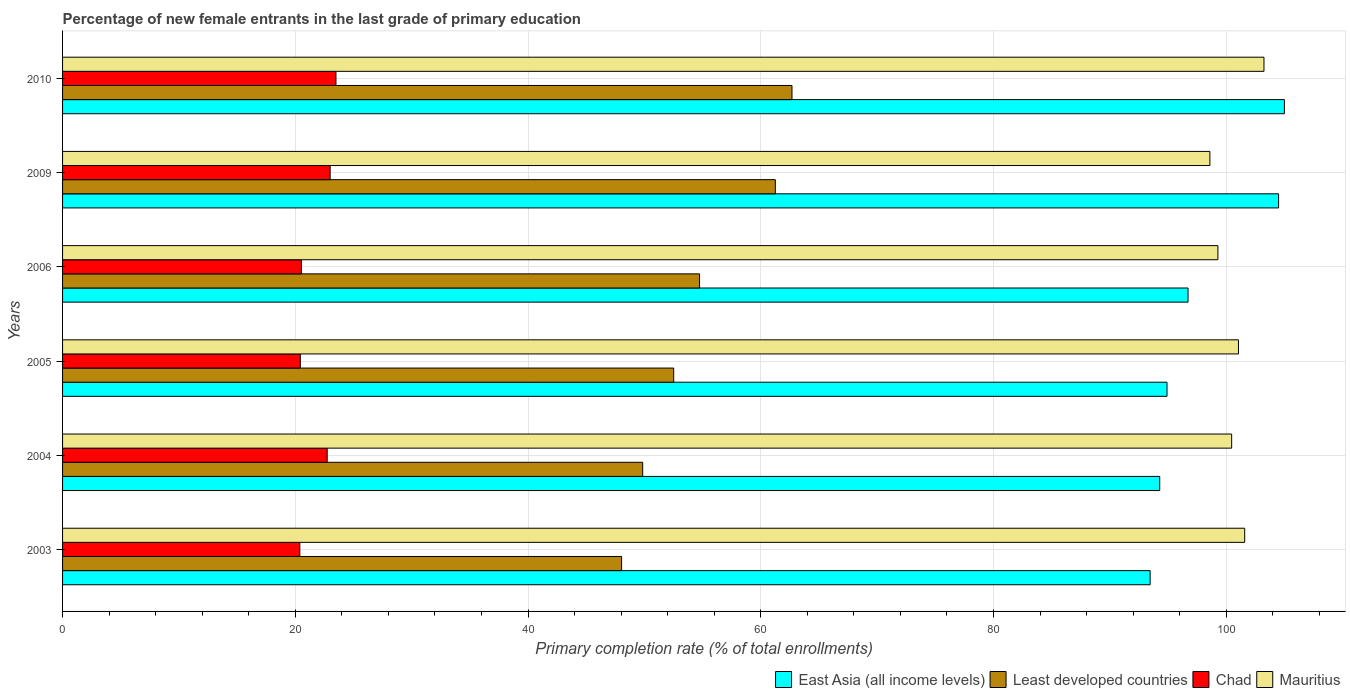How many different coloured bars are there?
Offer a very short reply. 4. How many bars are there on the 6th tick from the top?
Provide a succinct answer. 4. What is the label of the 6th group of bars from the top?
Ensure brevity in your answer.  2003. What is the percentage of new female entrants in Least developed countries in 2010?
Offer a very short reply. 62.68. Across all years, what is the maximum percentage of new female entrants in Least developed countries?
Your answer should be very brief. 62.68. Across all years, what is the minimum percentage of new female entrants in East Asia (all income levels)?
Provide a short and direct response. 93.46. What is the total percentage of new female entrants in East Asia (all income levels) in the graph?
Your answer should be compact. 588.85. What is the difference between the percentage of new female entrants in East Asia (all income levels) in 2004 and that in 2005?
Your response must be concise. -0.63. What is the difference between the percentage of new female entrants in East Asia (all income levels) in 2004 and the percentage of new female entrants in Chad in 2003?
Your answer should be very brief. 73.89. What is the average percentage of new female entrants in Chad per year?
Keep it short and to the point. 21.76. In the year 2005, what is the difference between the percentage of new female entrants in Least developed countries and percentage of new female entrants in East Asia (all income levels)?
Make the answer very short. -42.39. What is the ratio of the percentage of new female entrants in Mauritius in 2005 to that in 2009?
Your response must be concise. 1.02. Is the percentage of new female entrants in Mauritius in 2004 less than that in 2010?
Ensure brevity in your answer.  Yes. Is the difference between the percentage of new female entrants in Least developed countries in 2004 and 2005 greater than the difference between the percentage of new female entrants in East Asia (all income levels) in 2004 and 2005?
Ensure brevity in your answer.  No. What is the difference between the highest and the second highest percentage of new female entrants in Mauritius?
Provide a short and direct response. 1.66. What is the difference between the highest and the lowest percentage of new female entrants in Least developed countries?
Give a very brief answer. 14.64. What does the 4th bar from the top in 2010 represents?
Provide a succinct answer. East Asia (all income levels). What does the 1st bar from the bottom in 2009 represents?
Offer a terse response. East Asia (all income levels). Is it the case that in every year, the sum of the percentage of new female entrants in Chad and percentage of new female entrants in Least developed countries is greater than the percentage of new female entrants in Mauritius?
Your answer should be very brief. No. Are all the bars in the graph horizontal?
Give a very brief answer. Yes. How many years are there in the graph?
Offer a terse response. 6. What is the difference between two consecutive major ticks on the X-axis?
Your response must be concise. 20. Are the values on the major ticks of X-axis written in scientific E-notation?
Your answer should be compact. No. Does the graph contain grids?
Make the answer very short. Yes. How are the legend labels stacked?
Offer a terse response. Horizontal. What is the title of the graph?
Offer a very short reply. Percentage of new female entrants in the last grade of primary education. What is the label or title of the X-axis?
Your answer should be very brief. Primary completion rate (% of total enrollments). What is the Primary completion rate (% of total enrollments) in East Asia (all income levels) in 2003?
Offer a terse response. 93.46. What is the Primary completion rate (% of total enrollments) in Least developed countries in 2003?
Offer a very short reply. 48.04. What is the Primary completion rate (% of total enrollments) in Chad in 2003?
Your answer should be very brief. 20.39. What is the Primary completion rate (% of total enrollments) of Mauritius in 2003?
Keep it short and to the point. 101.58. What is the Primary completion rate (% of total enrollments) in East Asia (all income levels) in 2004?
Your answer should be compact. 94.28. What is the Primary completion rate (% of total enrollments) of Least developed countries in 2004?
Your answer should be very brief. 49.85. What is the Primary completion rate (% of total enrollments) in Chad in 2004?
Ensure brevity in your answer.  22.74. What is the Primary completion rate (% of total enrollments) of Mauritius in 2004?
Your answer should be very brief. 100.46. What is the Primary completion rate (% of total enrollments) in East Asia (all income levels) in 2005?
Offer a very short reply. 94.91. What is the Primary completion rate (% of total enrollments) of Least developed countries in 2005?
Keep it short and to the point. 52.52. What is the Primary completion rate (% of total enrollments) in Chad in 2005?
Provide a succinct answer. 20.43. What is the Primary completion rate (% of total enrollments) in Mauritius in 2005?
Keep it short and to the point. 101.05. What is the Primary completion rate (% of total enrollments) in East Asia (all income levels) in 2006?
Your answer should be very brief. 96.72. What is the Primary completion rate (% of total enrollments) of Least developed countries in 2006?
Provide a succinct answer. 54.74. What is the Primary completion rate (% of total enrollments) of Chad in 2006?
Offer a very short reply. 20.52. What is the Primary completion rate (% of total enrollments) of Mauritius in 2006?
Your answer should be compact. 99.28. What is the Primary completion rate (% of total enrollments) in East Asia (all income levels) in 2009?
Provide a succinct answer. 104.49. What is the Primary completion rate (% of total enrollments) of Least developed countries in 2009?
Your response must be concise. 61.25. What is the Primary completion rate (% of total enrollments) in Chad in 2009?
Your answer should be very brief. 22.99. What is the Primary completion rate (% of total enrollments) in Mauritius in 2009?
Your response must be concise. 98.59. What is the Primary completion rate (% of total enrollments) of East Asia (all income levels) in 2010?
Provide a succinct answer. 104.99. What is the Primary completion rate (% of total enrollments) in Least developed countries in 2010?
Your response must be concise. 62.68. What is the Primary completion rate (% of total enrollments) in Chad in 2010?
Offer a very short reply. 23.49. What is the Primary completion rate (% of total enrollments) of Mauritius in 2010?
Keep it short and to the point. 103.24. Across all years, what is the maximum Primary completion rate (% of total enrollments) of East Asia (all income levels)?
Make the answer very short. 104.99. Across all years, what is the maximum Primary completion rate (% of total enrollments) in Least developed countries?
Keep it short and to the point. 62.68. Across all years, what is the maximum Primary completion rate (% of total enrollments) in Chad?
Offer a very short reply. 23.49. Across all years, what is the maximum Primary completion rate (% of total enrollments) in Mauritius?
Your response must be concise. 103.24. Across all years, what is the minimum Primary completion rate (% of total enrollments) in East Asia (all income levels)?
Your answer should be compact. 93.46. Across all years, what is the minimum Primary completion rate (% of total enrollments) in Least developed countries?
Your answer should be very brief. 48.04. Across all years, what is the minimum Primary completion rate (% of total enrollments) of Chad?
Provide a short and direct response. 20.39. Across all years, what is the minimum Primary completion rate (% of total enrollments) in Mauritius?
Keep it short and to the point. 98.59. What is the total Primary completion rate (% of total enrollments) of East Asia (all income levels) in the graph?
Offer a very short reply. 588.85. What is the total Primary completion rate (% of total enrollments) in Least developed countries in the graph?
Your answer should be compact. 329.07. What is the total Primary completion rate (% of total enrollments) in Chad in the graph?
Offer a terse response. 130.57. What is the total Primary completion rate (% of total enrollments) of Mauritius in the graph?
Make the answer very short. 604.2. What is the difference between the Primary completion rate (% of total enrollments) of East Asia (all income levels) in 2003 and that in 2004?
Make the answer very short. -0.82. What is the difference between the Primary completion rate (% of total enrollments) in Least developed countries in 2003 and that in 2004?
Offer a terse response. -1.81. What is the difference between the Primary completion rate (% of total enrollments) in Chad in 2003 and that in 2004?
Your answer should be very brief. -2.35. What is the difference between the Primary completion rate (% of total enrollments) in Mauritius in 2003 and that in 2004?
Offer a terse response. 1.12. What is the difference between the Primary completion rate (% of total enrollments) of East Asia (all income levels) in 2003 and that in 2005?
Give a very brief answer. -1.45. What is the difference between the Primary completion rate (% of total enrollments) in Least developed countries in 2003 and that in 2005?
Your answer should be very brief. -4.48. What is the difference between the Primary completion rate (% of total enrollments) of Chad in 2003 and that in 2005?
Provide a short and direct response. -0.04. What is the difference between the Primary completion rate (% of total enrollments) of Mauritius in 2003 and that in 2005?
Your response must be concise. 0.53. What is the difference between the Primary completion rate (% of total enrollments) of East Asia (all income levels) in 2003 and that in 2006?
Your answer should be compact. -3.26. What is the difference between the Primary completion rate (% of total enrollments) in Least developed countries in 2003 and that in 2006?
Keep it short and to the point. -6.7. What is the difference between the Primary completion rate (% of total enrollments) in Chad in 2003 and that in 2006?
Keep it short and to the point. -0.13. What is the difference between the Primary completion rate (% of total enrollments) of Mauritius in 2003 and that in 2006?
Give a very brief answer. 2.3. What is the difference between the Primary completion rate (% of total enrollments) in East Asia (all income levels) in 2003 and that in 2009?
Keep it short and to the point. -11.04. What is the difference between the Primary completion rate (% of total enrollments) in Least developed countries in 2003 and that in 2009?
Your response must be concise. -13.21. What is the difference between the Primary completion rate (% of total enrollments) in Chad in 2003 and that in 2009?
Provide a succinct answer. -2.6. What is the difference between the Primary completion rate (% of total enrollments) in Mauritius in 2003 and that in 2009?
Provide a succinct answer. 2.99. What is the difference between the Primary completion rate (% of total enrollments) of East Asia (all income levels) in 2003 and that in 2010?
Your answer should be compact. -11.54. What is the difference between the Primary completion rate (% of total enrollments) in Least developed countries in 2003 and that in 2010?
Your answer should be compact. -14.64. What is the difference between the Primary completion rate (% of total enrollments) in Chad in 2003 and that in 2010?
Provide a short and direct response. -3.1. What is the difference between the Primary completion rate (% of total enrollments) in Mauritius in 2003 and that in 2010?
Offer a very short reply. -1.66. What is the difference between the Primary completion rate (% of total enrollments) in East Asia (all income levels) in 2004 and that in 2005?
Your answer should be compact. -0.63. What is the difference between the Primary completion rate (% of total enrollments) in Least developed countries in 2004 and that in 2005?
Keep it short and to the point. -2.67. What is the difference between the Primary completion rate (% of total enrollments) of Chad in 2004 and that in 2005?
Keep it short and to the point. 2.31. What is the difference between the Primary completion rate (% of total enrollments) of Mauritius in 2004 and that in 2005?
Offer a very short reply. -0.59. What is the difference between the Primary completion rate (% of total enrollments) of East Asia (all income levels) in 2004 and that in 2006?
Provide a succinct answer. -2.44. What is the difference between the Primary completion rate (% of total enrollments) of Least developed countries in 2004 and that in 2006?
Your answer should be very brief. -4.89. What is the difference between the Primary completion rate (% of total enrollments) in Chad in 2004 and that in 2006?
Give a very brief answer. 2.22. What is the difference between the Primary completion rate (% of total enrollments) in Mauritius in 2004 and that in 2006?
Offer a terse response. 1.18. What is the difference between the Primary completion rate (% of total enrollments) of East Asia (all income levels) in 2004 and that in 2009?
Ensure brevity in your answer.  -10.21. What is the difference between the Primary completion rate (% of total enrollments) in Least developed countries in 2004 and that in 2009?
Ensure brevity in your answer.  -11.4. What is the difference between the Primary completion rate (% of total enrollments) in Chad in 2004 and that in 2009?
Make the answer very short. -0.25. What is the difference between the Primary completion rate (% of total enrollments) of Mauritius in 2004 and that in 2009?
Your response must be concise. 1.87. What is the difference between the Primary completion rate (% of total enrollments) in East Asia (all income levels) in 2004 and that in 2010?
Provide a succinct answer. -10.71. What is the difference between the Primary completion rate (% of total enrollments) of Least developed countries in 2004 and that in 2010?
Give a very brief answer. -12.83. What is the difference between the Primary completion rate (% of total enrollments) of Chad in 2004 and that in 2010?
Your response must be concise. -0.75. What is the difference between the Primary completion rate (% of total enrollments) in Mauritius in 2004 and that in 2010?
Give a very brief answer. -2.78. What is the difference between the Primary completion rate (% of total enrollments) of East Asia (all income levels) in 2005 and that in 2006?
Provide a short and direct response. -1.81. What is the difference between the Primary completion rate (% of total enrollments) of Least developed countries in 2005 and that in 2006?
Make the answer very short. -2.22. What is the difference between the Primary completion rate (% of total enrollments) of Chad in 2005 and that in 2006?
Ensure brevity in your answer.  -0.09. What is the difference between the Primary completion rate (% of total enrollments) in Mauritius in 2005 and that in 2006?
Provide a short and direct response. 1.77. What is the difference between the Primary completion rate (% of total enrollments) in East Asia (all income levels) in 2005 and that in 2009?
Provide a short and direct response. -9.59. What is the difference between the Primary completion rate (% of total enrollments) in Least developed countries in 2005 and that in 2009?
Provide a succinct answer. -8.73. What is the difference between the Primary completion rate (% of total enrollments) of Chad in 2005 and that in 2009?
Offer a very short reply. -2.56. What is the difference between the Primary completion rate (% of total enrollments) in Mauritius in 2005 and that in 2009?
Your response must be concise. 2.46. What is the difference between the Primary completion rate (% of total enrollments) of East Asia (all income levels) in 2005 and that in 2010?
Keep it short and to the point. -10.09. What is the difference between the Primary completion rate (% of total enrollments) of Least developed countries in 2005 and that in 2010?
Make the answer very short. -10.16. What is the difference between the Primary completion rate (% of total enrollments) of Chad in 2005 and that in 2010?
Your answer should be compact. -3.06. What is the difference between the Primary completion rate (% of total enrollments) of Mauritius in 2005 and that in 2010?
Keep it short and to the point. -2.19. What is the difference between the Primary completion rate (% of total enrollments) of East Asia (all income levels) in 2006 and that in 2009?
Make the answer very short. -7.78. What is the difference between the Primary completion rate (% of total enrollments) in Least developed countries in 2006 and that in 2009?
Your response must be concise. -6.51. What is the difference between the Primary completion rate (% of total enrollments) of Chad in 2006 and that in 2009?
Your answer should be compact. -2.47. What is the difference between the Primary completion rate (% of total enrollments) of Mauritius in 2006 and that in 2009?
Your answer should be very brief. 0.69. What is the difference between the Primary completion rate (% of total enrollments) in East Asia (all income levels) in 2006 and that in 2010?
Your answer should be very brief. -8.28. What is the difference between the Primary completion rate (% of total enrollments) of Least developed countries in 2006 and that in 2010?
Provide a succinct answer. -7.94. What is the difference between the Primary completion rate (% of total enrollments) of Chad in 2006 and that in 2010?
Your answer should be very brief. -2.97. What is the difference between the Primary completion rate (% of total enrollments) in Mauritius in 2006 and that in 2010?
Provide a short and direct response. -3.96. What is the difference between the Primary completion rate (% of total enrollments) of East Asia (all income levels) in 2009 and that in 2010?
Offer a very short reply. -0.5. What is the difference between the Primary completion rate (% of total enrollments) in Least developed countries in 2009 and that in 2010?
Offer a very short reply. -1.43. What is the difference between the Primary completion rate (% of total enrollments) of Mauritius in 2009 and that in 2010?
Provide a succinct answer. -4.65. What is the difference between the Primary completion rate (% of total enrollments) in East Asia (all income levels) in 2003 and the Primary completion rate (% of total enrollments) in Least developed countries in 2004?
Offer a terse response. 43.61. What is the difference between the Primary completion rate (% of total enrollments) in East Asia (all income levels) in 2003 and the Primary completion rate (% of total enrollments) in Chad in 2004?
Make the answer very short. 70.72. What is the difference between the Primary completion rate (% of total enrollments) of East Asia (all income levels) in 2003 and the Primary completion rate (% of total enrollments) of Mauritius in 2004?
Give a very brief answer. -7. What is the difference between the Primary completion rate (% of total enrollments) in Least developed countries in 2003 and the Primary completion rate (% of total enrollments) in Chad in 2004?
Your answer should be compact. 25.3. What is the difference between the Primary completion rate (% of total enrollments) in Least developed countries in 2003 and the Primary completion rate (% of total enrollments) in Mauritius in 2004?
Your answer should be compact. -52.42. What is the difference between the Primary completion rate (% of total enrollments) in Chad in 2003 and the Primary completion rate (% of total enrollments) in Mauritius in 2004?
Give a very brief answer. -80.07. What is the difference between the Primary completion rate (% of total enrollments) of East Asia (all income levels) in 2003 and the Primary completion rate (% of total enrollments) of Least developed countries in 2005?
Offer a very short reply. 40.94. What is the difference between the Primary completion rate (% of total enrollments) in East Asia (all income levels) in 2003 and the Primary completion rate (% of total enrollments) in Chad in 2005?
Give a very brief answer. 73.03. What is the difference between the Primary completion rate (% of total enrollments) in East Asia (all income levels) in 2003 and the Primary completion rate (% of total enrollments) in Mauritius in 2005?
Ensure brevity in your answer.  -7.59. What is the difference between the Primary completion rate (% of total enrollments) of Least developed countries in 2003 and the Primary completion rate (% of total enrollments) of Chad in 2005?
Your response must be concise. 27.61. What is the difference between the Primary completion rate (% of total enrollments) in Least developed countries in 2003 and the Primary completion rate (% of total enrollments) in Mauritius in 2005?
Make the answer very short. -53.01. What is the difference between the Primary completion rate (% of total enrollments) of Chad in 2003 and the Primary completion rate (% of total enrollments) of Mauritius in 2005?
Your answer should be compact. -80.66. What is the difference between the Primary completion rate (% of total enrollments) of East Asia (all income levels) in 2003 and the Primary completion rate (% of total enrollments) of Least developed countries in 2006?
Offer a terse response. 38.72. What is the difference between the Primary completion rate (% of total enrollments) of East Asia (all income levels) in 2003 and the Primary completion rate (% of total enrollments) of Chad in 2006?
Your response must be concise. 72.94. What is the difference between the Primary completion rate (% of total enrollments) of East Asia (all income levels) in 2003 and the Primary completion rate (% of total enrollments) of Mauritius in 2006?
Offer a very short reply. -5.82. What is the difference between the Primary completion rate (% of total enrollments) in Least developed countries in 2003 and the Primary completion rate (% of total enrollments) in Chad in 2006?
Your response must be concise. 27.52. What is the difference between the Primary completion rate (% of total enrollments) in Least developed countries in 2003 and the Primary completion rate (% of total enrollments) in Mauritius in 2006?
Give a very brief answer. -51.24. What is the difference between the Primary completion rate (% of total enrollments) of Chad in 2003 and the Primary completion rate (% of total enrollments) of Mauritius in 2006?
Give a very brief answer. -78.89. What is the difference between the Primary completion rate (% of total enrollments) of East Asia (all income levels) in 2003 and the Primary completion rate (% of total enrollments) of Least developed countries in 2009?
Provide a short and direct response. 32.21. What is the difference between the Primary completion rate (% of total enrollments) in East Asia (all income levels) in 2003 and the Primary completion rate (% of total enrollments) in Chad in 2009?
Give a very brief answer. 70.46. What is the difference between the Primary completion rate (% of total enrollments) of East Asia (all income levels) in 2003 and the Primary completion rate (% of total enrollments) of Mauritius in 2009?
Provide a short and direct response. -5.13. What is the difference between the Primary completion rate (% of total enrollments) of Least developed countries in 2003 and the Primary completion rate (% of total enrollments) of Chad in 2009?
Provide a succinct answer. 25.05. What is the difference between the Primary completion rate (% of total enrollments) in Least developed countries in 2003 and the Primary completion rate (% of total enrollments) in Mauritius in 2009?
Your answer should be compact. -50.55. What is the difference between the Primary completion rate (% of total enrollments) in Chad in 2003 and the Primary completion rate (% of total enrollments) in Mauritius in 2009?
Give a very brief answer. -78.2. What is the difference between the Primary completion rate (% of total enrollments) in East Asia (all income levels) in 2003 and the Primary completion rate (% of total enrollments) in Least developed countries in 2010?
Keep it short and to the point. 30.78. What is the difference between the Primary completion rate (% of total enrollments) of East Asia (all income levels) in 2003 and the Primary completion rate (% of total enrollments) of Chad in 2010?
Offer a terse response. 69.96. What is the difference between the Primary completion rate (% of total enrollments) of East Asia (all income levels) in 2003 and the Primary completion rate (% of total enrollments) of Mauritius in 2010?
Provide a succinct answer. -9.78. What is the difference between the Primary completion rate (% of total enrollments) of Least developed countries in 2003 and the Primary completion rate (% of total enrollments) of Chad in 2010?
Keep it short and to the point. 24.55. What is the difference between the Primary completion rate (% of total enrollments) of Least developed countries in 2003 and the Primary completion rate (% of total enrollments) of Mauritius in 2010?
Give a very brief answer. -55.2. What is the difference between the Primary completion rate (% of total enrollments) in Chad in 2003 and the Primary completion rate (% of total enrollments) in Mauritius in 2010?
Provide a short and direct response. -82.85. What is the difference between the Primary completion rate (% of total enrollments) in East Asia (all income levels) in 2004 and the Primary completion rate (% of total enrollments) in Least developed countries in 2005?
Your answer should be very brief. 41.76. What is the difference between the Primary completion rate (% of total enrollments) of East Asia (all income levels) in 2004 and the Primary completion rate (% of total enrollments) of Chad in 2005?
Your answer should be compact. 73.85. What is the difference between the Primary completion rate (% of total enrollments) of East Asia (all income levels) in 2004 and the Primary completion rate (% of total enrollments) of Mauritius in 2005?
Your answer should be very brief. -6.77. What is the difference between the Primary completion rate (% of total enrollments) of Least developed countries in 2004 and the Primary completion rate (% of total enrollments) of Chad in 2005?
Provide a succinct answer. 29.42. What is the difference between the Primary completion rate (% of total enrollments) in Least developed countries in 2004 and the Primary completion rate (% of total enrollments) in Mauritius in 2005?
Your answer should be very brief. -51.2. What is the difference between the Primary completion rate (% of total enrollments) of Chad in 2004 and the Primary completion rate (% of total enrollments) of Mauritius in 2005?
Your answer should be compact. -78.31. What is the difference between the Primary completion rate (% of total enrollments) in East Asia (all income levels) in 2004 and the Primary completion rate (% of total enrollments) in Least developed countries in 2006?
Your response must be concise. 39.54. What is the difference between the Primary completion rate (% of total enrollments) of East Asia (all income levels) in 2004 and the Primary completion rate (% of total enrollments) of Chad in 2006?
Keep it short and to the point. 73.76. What is the difference between the Primary completion rate (% of total enrollments) in East Asia (all income levels) in 2004 and the Primary completion rate (% of total enrollments) in Mauritius in 2006?
Offer a very short reply. -5. What is the difference between the Primary completion rate (% of total enrollments) in Least developed countries in 2004 and the Primary completion rate (% of total enrollments) in Chad in 2006?
Offer a terse response. 29.33. What is the difference between the Primary completion rate (% of total enrollments) in Least developed countries in 2004 and the Primary completion rate (% of total enrollments) in Mauritius in 2006?
Offer a very short reply. -49.43. What is the difference between the Primary completion rate (% of total enrollments) in Chad in 2004 and the Primary completion rate (% of total enrollments) in Mauritius in 2006?
Make the answer very short. -76.54. What is the difference between the Primary completion rate (% of total enrollments) in East Asia (all income levels) in 2004 and the Primary completion rate (% of total enrollments) in Least developed countries in 2009?
Offer a terse response. 33.03. What is the difference between the Primary completion rate (% of total enrollments) of East Asia (all income levels) in 2004 and the Primary completion rate (% of total enrollments) of Chad in 2009?
Give a very brief answer. 71.29. What is the difference between the Primary completion rate (% of total enrollments) of East Asia (all income levels) in 2004 and the Primary completion rate (% of total enrollments) of Mauritius in 2009?
Your response must be concise. -4.31. What is the difference between the Primary completion rate (% of total enrollments) of Least developed countries in 2004 and the Primary completion rate (% of total enrollments) of Chad in 2009?
Offer a very short reply. 26.86. What is the difference between the Primary completion rate (% of total enrollments) of Least developed countries in 2004 and the Primary completion rate (% of total enrollments) of Mauritius in 2009?
Offer a terse response. -48.74. What is the difference between the Primary completion rate (% of total enrollments) of Chad in 2004 and the Primary completion rate (% of total enrollments) of Mauritius in 2009?
Your response must be concise. -75.85. What is the difference between the Primary completion rate (% of total enrollments) of East Asia (all income levels) in 2004 and the Primary completion rate (% of total enrollments) of Least developed countries in 2010?
Your response must be concise. 31.6. What is the difference between the Primary completion rate (% of total enrollments) in East Asia (all income levels) in 2004 and the Primary completion rate (% of total enrollments) in Chad in 2010?
Offer a terse response. 70.79. What is the difference between the Primary completion rate (% of total enrollments) in East Asia (all income levels) in 2004 and the Primary completion rate (% of total enrollments) in Mauritius in 2010?
Offer a very short reply. -8.96. What is the difference between the Primary completion rate (% of total enrollments) of Least developed countries in 2004 and the Primary completion rate (% of total enrollments) of Chad in 2010?
Offer a very short reply. 26.36. What is the difference between the Primary completion rate (% of total enrollments) of Least developed countries in 2004 and the Primary completion rate (% of total enrollments) of Mauritius in 2010?
Ensure brevity in your answer.  -53.39. What is the difference between the Primary completion rate (% of total enrollments) in Chad in 2004 and the Primary completion rate (% of total enrollments) in Mauritius in 2010?
Your response must be concise. -80.5. What is the difference between the Primary completion rate (% of total enrollments) in East Asia (all income levels) in 2005 and the Primary completion rate (% of total enrollments) in Least developed countries in 2006?
Give a very brief answer. 40.17. What is the difference between the Primary completion rate (% of total enrollments) of East Asia (all income levels) in 2005 and the Primary completion rate (% of total enrollments) of Chad in 2006?
Offer a terse response. 74.39. What is the difference between the Primary completion rate (% of total enrollments) of East Asia (all income levels) in 2005 and the Primary completion rate (% of total enrollments) of Mauritius in 2006?
Keep it short and to the point. -4.37. What is the difference between the Primary completion rate (% of total enrollments) of Least developed countries in 2005 and the Primary completion rate (% of total enrollments) of Chad in 2006?
Keep it short and to the point. 31.99. What is the difference between the Primary completion rate (% of total enrollments) of Least developed countries in 2005 and the Primary completion rate (% of total enrollments) of Mauritius in 2006?
Your answer should be compact. -46.76. What is the difference between the Primary completion rate (% of total enrollments) in Chad in 2005 and the Primary completion rate (% of total enrollments) in Mauritius in 2006?
Provide a short and direct response. -78.85. What is the difference between the Primary completion rate (% of total enrollments) of East Asia (all income levels) in 2005 and the Primary completion rate (% of total enrollments) of Least developed countries in 2009?
Give a very brief answer. 33.66. What is the difference between the Primary completion rate (% of total enrollments) of East Asia (all income levels) in 2005 and the Primary completion rate (% of total enrollments) of Chad in 2009?
Your answer should be compact. 71.91. What is the difference between the Primary completion rate (% of total enrollments) in East Asia (all income levels) in 2005 and the Primary completion rate (% of total enrollments) in Mauritius in 2009?
Provide a short and direct response. -3.68. What is the difference between the Primary completion rate (% of total enrollments) in Least developed countries in 2005 and the Primary completion rate (% of total enrollments) in Chad in 2009?
Keep it short and to the point. 29.52. What is the difference between the Primary completion rate (% of total enrollments) of Least developed countries in 2005 and the Primary completion rate (% of total enrollments) of Mauritius in 2009?
Offer a terse response. -46.08. What is the difference between the Primary completion rate (% of total enrollments) of Chad in 2005 and the Primary completion rate (% of total enrollments) of Mauritius in 2009?
Ensure brevity in your answer.  -78.16. What is the difference between the Primary completion rate (% of total enrollments) of East Asia (all income levels) in 2005 and the Primary completion rate (% of total enrollments) of Least developed countries in 2010?
Give a very brief answer. 32.23. What is the difference between the Primary completion rate (% of total enrollments) of East Asia (all income levels) in 2005 and the Primary completion rate (% of total enrollments) of Chad in 2010?
Offer a very short reply. 71.42. What is the difference between the Primary completion rate (% of total enrollments) of East Asia (all income levels) in 2005 and the Primary completion rate (% of total enrollments) of Mauritius in 2010?
Provide a succinct answer. -8.33. What is the difference between the Primary completion rate (% of total enrollments) of Least developed countries in 2005 and the Primary completion rate (% of total enrollments) of Chad in 2010?
Your response must be concise. 29.02. What is the difference between the Primary completion rate (% of total enrollments) of Least developed countries in 2005 and the Primary completion rate (% of total enrollments) of Mauritius in 2010?
Offer a terse response. -50.72. What is the difference between the Primary completion rate (% of total enrollments) in Chad in 2005 and the Primary completion rate (% of total enrollments) in Mauritius in 2010?
Make the answer very short. -82.81. What is the difference between the Primary completion rate (% of total enrollments) of East Asia (all income levels) in 2006 and the Primary completion rate (% of total enrollments) of Least developed countries in 2009?
Provide a short and direct response. 35.46. What is the difference between the Primary completion rate (% of total enrollments) of East Asia (all income levels) in 2006 and the Primary completion rate (% of total enrollments) of Chad in 2009?
Provide a short and direct response. 73.72. What is the difference between the Primary completion rate (% of total enrollments) of East Asia (all income levels) in 2006 and the Primary completion rate (% of total enrollments) of Mauritius in 2009?
Offer a very short reply. -1.88. What is the difference between the Primary completion rate (% of total enrollments) of Least developed countries in 2006 and the Primary completion rate (% of total enrollments) of Chad in 2009?
Make the answer very short. 31.75. What is the difference between the Primary completion rate (% of total enrollments) in Least developed countries in 2006 and the Primary completion rate (% of total enrollments) in Mauritius in 2009?
Offer a terse response. -43.85. What is the difference between the Primary completion rate (% of total enrollments) in Chad in 2006 and the Primary completion rate (% of total enrollments) in Mauritius in 2009?
Offer a terse response. -78.07. What is the difference between the Primary completion rate (% of total enrollments) of East Asia (all income levels) in 2006 and the Primary completion rate (% of total enrollments) of Least developed countries in 2010?
Give a very brief answer. 34.04. What is the difference between the Primary completion rate (% of total enrollments) of East Asia (all income levels) in 2006 and the Primary completion rate (% of total enrollments) of Chad in 2010?
Keep it short and to the point. 73.22. What is the difference between the Primary completion rate (% of total enrollments) of East Asia (all income levels) in 2006 and the Primary completion rate (% of total enrollments) of Mauritius in 2010?
Give a very brief answer. -6.52. What is the difference between the Primary completion rate (% of total enrollments) in Least developed countries in 2006 and the Primary completion rate (% of total enrollments) in Chad in 2010?
Ensure brevity in your answer.  31.25. What is the difference between the Primary completion rate (% of total enrollments) of Least developed countries in 2006 and the Primary completion rate (% of total enrollments) of Mauritius in 2010?
Keep it short and to the point. -48.5. What is the difference between the Primary completion rate (% of total enrollments) of Chad in 2006 and the Primary completion rate (% of total enrollments) of Mauritius in 2010?
Offer a very short reply. -82.72. What is the difference between the Primary completion rate (% of total enrollments) in East Asia (all income levels) in 2009 and the Primary completion rate (% of total enrollments) in Least developed countries in 2010?
Give a very brief answer. 41.81. What is the difference between the Primary completion rate (% of total enrollments) in East Asia (all income levels) in 2009 and the Primary completion rate (% of total enrollments) in Chad in 2010?
Make the answer very short. 81. What is the difference between the Primary completion rate (% of total enrollments) of East Asia (all income levels) in 2009 and the Primary completion rate (% of total enrollments) of Mauritius in 2010?
Provide a short and direct response. 1.25. What is the difference between the Primary completion rate (% of total enrollments) in Least developed countries in 2009 and the Primary completion rate (% of total enrollments) in Chad in 2010?
Make the answer very short. 37.76. What is the difference between the Primary completion rate (% of total enrollments) of Least developed countries in 2009 and the Primary completion rate (% of total enrollments) of Mauritius in 2010?
Keep it short and to the point. -41.99. What is the difference between the Primary completion rate (% of total enrollments) of Chad in 2009 and the Primary completion rate (% of total enrollments) of Mauritius in 2010?
Provide a short and direct response. -80.25. What is the average Primary completion rate (% of total enrollments) of East Asia (all income levels) per year?
Ensure brevity in your answer.  98.14. What is the average Primary completion rate (% of total enrollments) in Least developed countries per year?
Give a very brief answer. 54.85. What is the average Primary completion rate (% of total enrollments) in Chad per year?
Give a very brief answer. 21.76. What is the average Primary completion rate (% of total enrollments) of Mauritius per year?
Give a very brief answer. 100.7. In the year 2003, what is the difference between the Primary completion rate (% of total enrollments) in East Asia (all income levels) and Primary completion rate (% of total enrollments) in Least developed countries?
Offer a terse response. 45.42. In the year 2003, what is the difference between the Primary completion rate (% of total enrollments) of East Asia (all income levels) and Primary completion rate (% of total enrollments) of Chad?
Keep it short and to the point. 73.07. In the year 2003, what is the difference between the Primary completion rate (% of total enrollments) of East Asia (all income levels) and Primary completion rate (% of total enrollments) of Mauritius?
Your response must be concise. -8.12. In the year 2003, what is the difference between the Primary completion rate (% of total enrollments) in Least developed countries and Primary completion rate (% of total enrollments) in Chad?
Your response must be concise. 27.65. In the year 2003, what is the difference between the Primary completion rate (% of total enrollments) in Least developed countries and Primary completion rate (% of total enrollments) in Mauritius?
Provide a succinct answer. -53.54. In the year 2003, what is the difference between the Primary completion rate (% of total enrollments) in Chad and Primary completion rate (% of total enrollments) in Mauritius?
Make the answer very short. -81.19. In the year 2004, what is the difference between the Primary completion rate (% of total enrollments) of East Asia (all income levels) and Primary completion rate (% of total enrollments) of Least developed countries?
Give a very brief answer. 44.43. In the year 2004, what is the difference between the Primary completion rate (% of total enrollments) of East Asia (all income levels) and Primary completion rate (% of total enrollments) of Chad?
Provide a succinct answer. 71.54. In the year 2004, what is the difference between the Primary completion rate (% of total enrollments) in East Asia (all income levels) and Primary completion rate (% of total enrollments) in Mauritius?
Ensure brevity in your answer.  -6.18. In the year 2004, what is the difference between the Primary completion rate (% of total enrollments) in Least developed countries and Primary completion rate (% of total enrollments) in Chad?
Provide a short and direct response. 27.11. In the year 2004, what is the difference between the Primary completion rate (% of total enrollments) of Least developed countries and Primary completion rate (% of total enrollments) of Mauritius?
Ensure brevity in your answer.  -50.61. In the year 2004, what is the difference between the Primary completion rate (% of total enrollments) of Chad and Primary completion rate (% of total enrollments) of Mauritius?
Make the answer very short. -77.72. In the year 2005, what is the difference between the Primary completion rate (% of total enrollments) of East Asia (all income levels) and Primary completion rate (% of total enrollments) of Least developed countries?
Provide a succinct answer. 42.39. In the year 2005, what is the difference between the Primary completion rate (% of total enrollments) of East Asia (all income levels) and Primary completion rate (% of total enrollments) of Chad?
Your answer should be very brief. 74.48. In the year 2005, what is the difference between the Primary completion rate (% of total enrollments) of East Asia (all income levels) and Primary completion rate (% of total enrollments) of Mauritius?
Give a very brief answer. -6.14. In the year 2005, what is the difference between the Primary completion rate (% of total enrollments) of Least developed countries and Primary completion rate (% of total enrollments) of Chad?
Your answer should be compact. 32.09. In the year 2005, what is the difference between the Primary completion rate (% of total enrollments) in Least developed countries and Primary completion rate (% of total enrollments) in Mauritius?
Your response must be concise. -48.53. In the year 2005, what is the difference between the Primary completion rate (% of total enrollments) in Chad and Primary completion rate (% of total enrollments) in Mauritius?
Keep it short and to the point. -80.62. In the year 2006, what is the difference between the Primary completion rate (% of total enrollments) of East Asia (all income levels) and Primary completion rate (% of total enrollments) of Least developed countries?
Give a very brief answer. 41.98. In the year 2006, what is the difference between the Primary completion rate (% of total enrollments) of East Asia (all income levels) and Primary completion rate (% of total enrollments) of Chad?
Keep it short and to the point. 76.19. In the year 2006, what is the difference between the Primary completion rate (% of total enrollments) of East Asia (all income levels) and Primary completion rate (% of total enrollments) of Mauritius?
Provide a succinct answer. -2.57. In the year 2006, what is the difference between the Primary completion rate (% of total enrollments) of Least developed countries and Primary completion rate (% of total enrollments) of Chad?
Keep it short and to the point. 34.22. In the year 2006, what is the difference between the Primary completion rate (% of total enrollments) in Least developed countries and Primary completion rate (% of total enrollments) in Mauritius?
Provide a short and direct response. -44.54. In the year 2006, what is the difference between the Primary completion rate (% of total enrollments) of Chad and Primary completion rate (% of total enrollments) of Mauritius?
Offer a terse response. -78.76. In the year 2009, what is the difference between the Primary completion rate (% of total enrollments) in East Asia (all income levels) and Primary completion rate (% of total enrollments) in Least developed countries?
Offer a terse response. 43.24. In the year 2009, what is the difference between the Primary completion rate (% of total enrollments) in East Asia (all income levels) and Primary completion rate (% of total enrollments) in Chad?
Ensure brevity in your answer.  81.5. In the year 2009, what is the difference between the Primary completion rate (% of total enrollments) in East Asia (all income levels) and Primary completion rate (% of total enrollments) in Mauritius?
Give a very brief answer. 5.9. In the year 2009, what is the difference between the Primary completion rate (% of total enrollments) of Least developed countries and Primary completion rate (% of total enrollments) of Chad?
Offer a terse response. 38.26. In the year 2009, what is the difference between the Primary completion rate (% of total enrollments) of Least developed countries and Primary completion rate (% of total enrollments) of Mauritius?
Keep it short and to the point. -37.34. In the year 2009, what is the difference between the Primary completion rate (% of total enrollments) of Chad and Primary completion rate (% of total enrollments) of Mauritius?
Ensure brevity in your answer.  -75.6. In the year 2010, what is the difference between the Primary completion rate (% of total enrollments) in East Asia (all income levels) and Primary completion rate (% of total enrollments) in Least developed countries?
Your answer should be very brief. 42.31. In the year 2010, what is the difference between the Primary completion rate (% of total enrollments) in East Asia (all income levels) and Primary completion rate (% of total enrollments) in Chad?
Provide a short and direct response. 81.5. In the year 2010, what is the difference between the Primary completion rate (% of total enrollments) in East Asia (all income levels) and Primary completion rate (% of total enrollments) in Mauritius?
Your response must be concise. 1.76. In the year 2010, what is the difference between the Primary completion rate (% of total enrollments) of Least developed countries and Primary completion rate (% of total enrollments) of Chad?
Offer a terse response. 39.19. In the year 2010, what is the difference between the Primary completion rate (% of total enrollments) of Least developed countries and Primary completion rate (% of total enrollments) of Mauritius?
Your answer should be compact. -40.56. In the year 2010, what is the difference between the Primary completion rate (% of total enrollments) in Chad and Primary completion rate (% of total enrollments) in Mauritius?
Keep it short and to the point. -79.75. What is the ratio of the Primary completion rate (% of total enrollments) in Least developed countries in 2003 to that in 2004?
Your response must be concise. 0.96. What is the ratio of the Primary completion rate (% of total enrollments) in Chad in 2003 to that in 2004?
Give a very brief answer. 0.9. What is the ratio of the Primary completion rate (% of total enrollments) of Mauritius in 2003 to that in 2004?
Keep it short and to the point. 1.01. What is the ratio of the Primary completion rate (% of total enrollments) of East Asia (all income levels) in 2003 to that in 2005?
Your answer should be very brief. 0.98. What is the ratio of the Primary completion rate (% of total enrollments) in Least developed countries in 2003 to that in 2005?
Give a very brief answer. 0.91. What is the ratio of the Primary completion rate (% of total enrollments) in East Asia (all income levels) in 2003 to that in 2006?
Your answer should be very brief. 0.97. What is the ratio of the Primary completion rate (% of total enrollments) in Least developed countries in 2003 to that in 2006?
Your response must be concise. 0.88. What is the ratio of the Primary completion rate (% of total enrollments) of Chad in 2003 to that in 2006?
Keep it short and to the point. 0.99. What is the ratio of the Primary completion rate (% of total enrollments) in Mauritius in 2003 to that in 2006?
Offer a terse response. 1.02. What is the ratio of the Primary completion rate (% of total enrollments) of East Asia (all income levels) in 2003 to that in 2009?
Your answer should be compact. 0.89. What is the ratio of the Primary completion rate (% of total enrollments) in Least developed countries in 2003 to that in 2009?
Give a very brief answer. 0.78. What is the ratio of the Primary completion rate (% of total enrollments) in Chad in 2003 to that in 2009?
Ensure brevity in your answer.  0.89. What is the ratio of the Primary completion rate (% of total enrollments) of Mauritius in 2003 to that in 2009?
Provide a short and direct response. 1.03. What is the ratio of the Primary completion rate (% of total enrollments) in East Asia (all income levels) in 2003 to that in 2010?
Provide a succinct answer. 0.89. What is the ratio of the Primary completion rate (% of total enrollments) of Least developed countries in 2003 to that in 2010?
Your response must be concise. 0.77. What is the ratio of the Primary completion rate (% of total enrollments) in Chad in 2003 to that in 2010?
Your answer should be very brief. 0.87. What is the ratio of the Primary completion rate (% of total enrollments) in Mauritius in 2003 to that in 2010?
Keep it short and to the point. 0.98. What is the ratio of the Primary completion rate (% of total enrollments) of Least developed countries in 2004 to that in 2005?
Offer a terse response. 0.95. What is the ratio of the Primary completion rate (% of total enrollments) of Chad in 2004 to that in 2005?
Give a very brief answer. 1.11. What is the ratio of the Primary completion rate (% of total enrollments) of East Asia (all income levels) in 2004 to that in 2006?
Offer a very short reply. 0.97. What is the ratio of the Primary completion rate (% of total enrollments) in Least developed countries in 2004 to that in 2006?
Your response must be concise. 0.91. What is the ratio of the Primary completion rate (% of total enrollments) of Chad in 2004 to that in 2006?
Offer a very short reply. 1.11. What is the ratio of the Primary completion rate (% of total enrollments) in Mauritius in 2004 to that in 2006?
Your response must be concise. 1.01. What is the ratio of the Primary completion rate (% of total enrollments) in East Asia (all income levels) in 2004 to that in 2009?
Give a very brief answer. 0.9. What is the ratio of the Primary completion rate (% of total enrollments) of Least developed countries in 2004 to that in 2009?
Keep it short and to the point. 0.81. What is the ratio of the Primary completion rate (% of total enrollments) of Chad in 2004 to that in 2009?
Offer a terse response. 0.99. What is the ratio of the Primary completion rate (% of total enrollments) of East Asia (all income levels) in 2004 to that in 2010?
Ensure brevity in your answer.  0.9. What is the ratio of the Primary completion rate (% of total enrollments) of Least developed countries in 2004 to that in 2010?
Your answer should be compact. 0.8. What is the ratio of the Primary completion rate (% of total enrollments) of Chad in 2004 to that in 2010?
Make the answer very short. 0.97. What is the ratio of the Primary completion rate (% of total enrollments) of Mauritius in 2004 to that in 2010?
Offer a terse response. 0.97. What is the ratio of the Primary completion rate (% of total enrollments) in East Asia (all income levels) in 2005 to that in 2006?
Ensure brevity in your answer.  0.98. What is the ratio of the Primary completion rate (% of total enrollments) in Least developed countries in 2005 to that in 2006?
Your answer should be very brief. 0.96. What is the ratio of the Primary completion rate (% of total enrollments) in Mauritius in 2005 to that in 2006?
Offer a very short reply. 1.02. What is the ratio of the Primary completion rate (% of total enrollments) of East Asia (all income levels) in 2005 to that in 2009?
Keep it short and to the point. 0.91. What is the ratio of the Primary completion rate (% of total enrollments) in Least developed countries in 2005 to that in 2009?
Ensure brevity in your answer.  0.86. What is the ratio of the Primary completion rate (% of total enrollments) of Chad in 2005 to that in 2009?
Keep it short and to the point. 0.89. What is the ratio of the Primary completion rate (% of total enrollments) in Mauritius in 2005 to that in 2009?
Your answer should be very brief. 1.02. What is the ratio of the Primary completion rate (% of total enrollments) of East Asia (all income levels) in 2005 to that in 2010?
Your answer should be very brief. 0.9. What is the ratio of the Primary completion rate (% of total enrollments) of Least developed countries in 2005 to that in 2010?
Ensure brevity in your answer.  0.84. What is the ratio of the Primary completion rate (% of total enrollments) in Chad in 2005 to that in 2010?
Your response must be concise. 0.87. What is the ratio of the Primary completion rate (% of total enrollments) of Mauritius in 2005 to that in 2010?
Your answer should be compact. 0.98. What is the ratio of the Primary completion rate (% of total enrollments) in East Asia (all income levels) in 2006 to that in 2009?
Keep it short and to the point. 0.93. What is the ratio of the Primary completion rate (% of total enrollments) of Least developed countries in 2006 to that in 2009?
Keep it short and to the point. 0.89. What is the ratio of the Primary completion rate (% of total enrollments) in Chad in 2006 to that in 2009?
Ensure brevity in your answer.  0.89. What is the ratio of the Primary completion rate (% of total enrollments) of Mauritius in 2006 to that in 2009?
Provide a short and direct response. 1.01. What is the ratio of the Primary completion rate (% of total enrollments) in East Asia (all income levels) in 2006 to that in 2010?
Your answer should be very brief. 0.92. What is the ratio of the Primary completion rate (% of total enrollments) in Least developed countries in 2006 to that in 2010?
Provide a short and direct response. 0.87. What is the ratio of the Primary completion rate (% of total enrollments) in Chad in 2006 to that in 2010?
Your response must be concise. 0.87. What is the ratio of the Primary completion rate (% of total enrollments) of Mauritius in 2006 to that in 2010?
Make the answer very short. 0.96. What is the ratio of the Primary completion rate (% of total enrollments) of Least developed countries in 2009 to that in 2010?
Provide a short and direct response. 0.98. What is the ratio of the Primary completion rate (% of total enrollments) in Chad in 2009 to that in 2010?
Offer a terse response. 0.98. What is the ratio of the Primary completion rate (% of total enrollments) of Mauritius in 2009 to that in 2010?
Give a very brief answer. 0.95. What is the difference between the highest and the second highest Primary completion rate (% of total enrollments) of East Asia (all income levels)?
Offer a very short reply. 0.5. What is the difference between the highest and the second highest Primary completion rate (% of total enrollments) of Least developed countries?
Keep it short and to the point. 1.43. What is the difference between the highest and the second highest Primary completion rate (% of total enrollments) in Chad?
Your response must be concise. 0.5. What is the difference between the highest and the second highest Primary completion rate (% of total enrollments) of Mauritius?
Provide a succinct answer. 1.66. What is the difference between the highest and the lowest Primary completion rate (% of total enrollments) in East Asia (all income levels)?
Your answer should be compact. 11.54. What is the difference between the highest and the lowest Primary completion rate (% of total enrollments) of Least developed countries?
Offer a terse response. 14.64. What is the difference between the highest and the lowest Primary completion rate (% of total enrollments) in Chad?
Keep it short and to the point. 3.1. What is the difference between the highest and the lowest Primary completion rate (% of total enrollments) of Mauritius?
Your answer should be very brief. 4.65. 